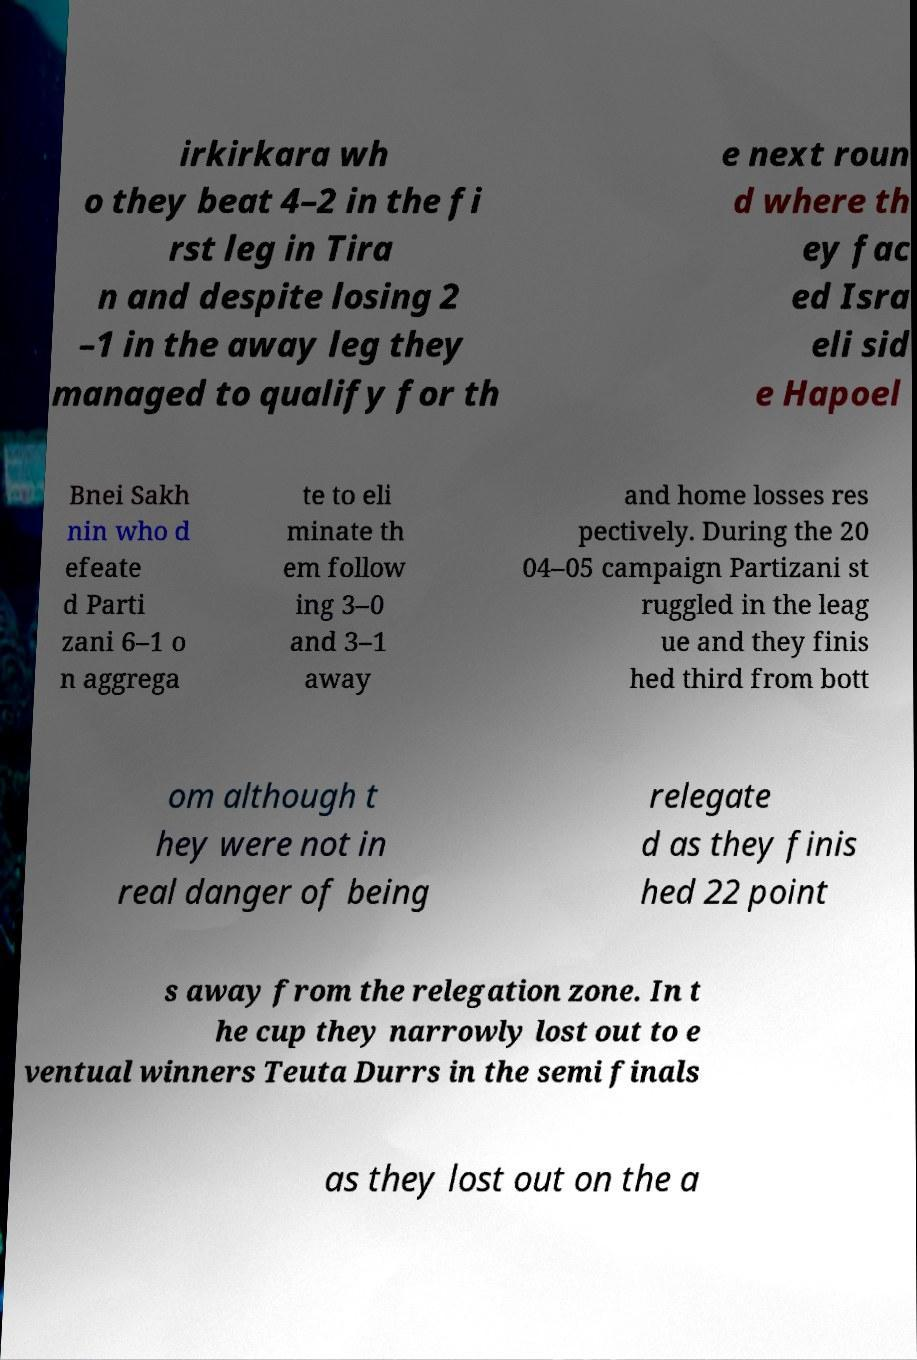Could you assist in decoding the text presented in this image and type it out clearly? irkirkara wh o they beat 4–2 in the fi rst leg in Tira n and despite losing 2 –1 in the away leg they managed to qualify for th e next roun d where th ey fac ed Isra eli sid e Hapoel Bnei Sakh nin who d efeate d Parti zani 6–1 o n aggrega te to eli minate th em follow ing 3–0 and 3–1 away and home losses res pectively. During the 20 04–05 campaign Partizani st ruggled in the leag ue and they finis hed third from bott om although t hey were not in real danger of being relegate d as they finis hed 22 point s away from the relegation zone. In t he cup they narrowly lost out to e ventual winners Teuta Durrs in the semi finals as they lost out on the a 